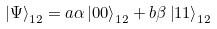<formula> <loc_0><loc_0><loc_500><loc_500>\left | \Psi \right \rangle _ { 1 2 } = a \alpha \left | 0 0 \right \rangle _ { 1 2 } + b \beta \left | 1 1 \right \rangle _ { 1 2 }</formula> 